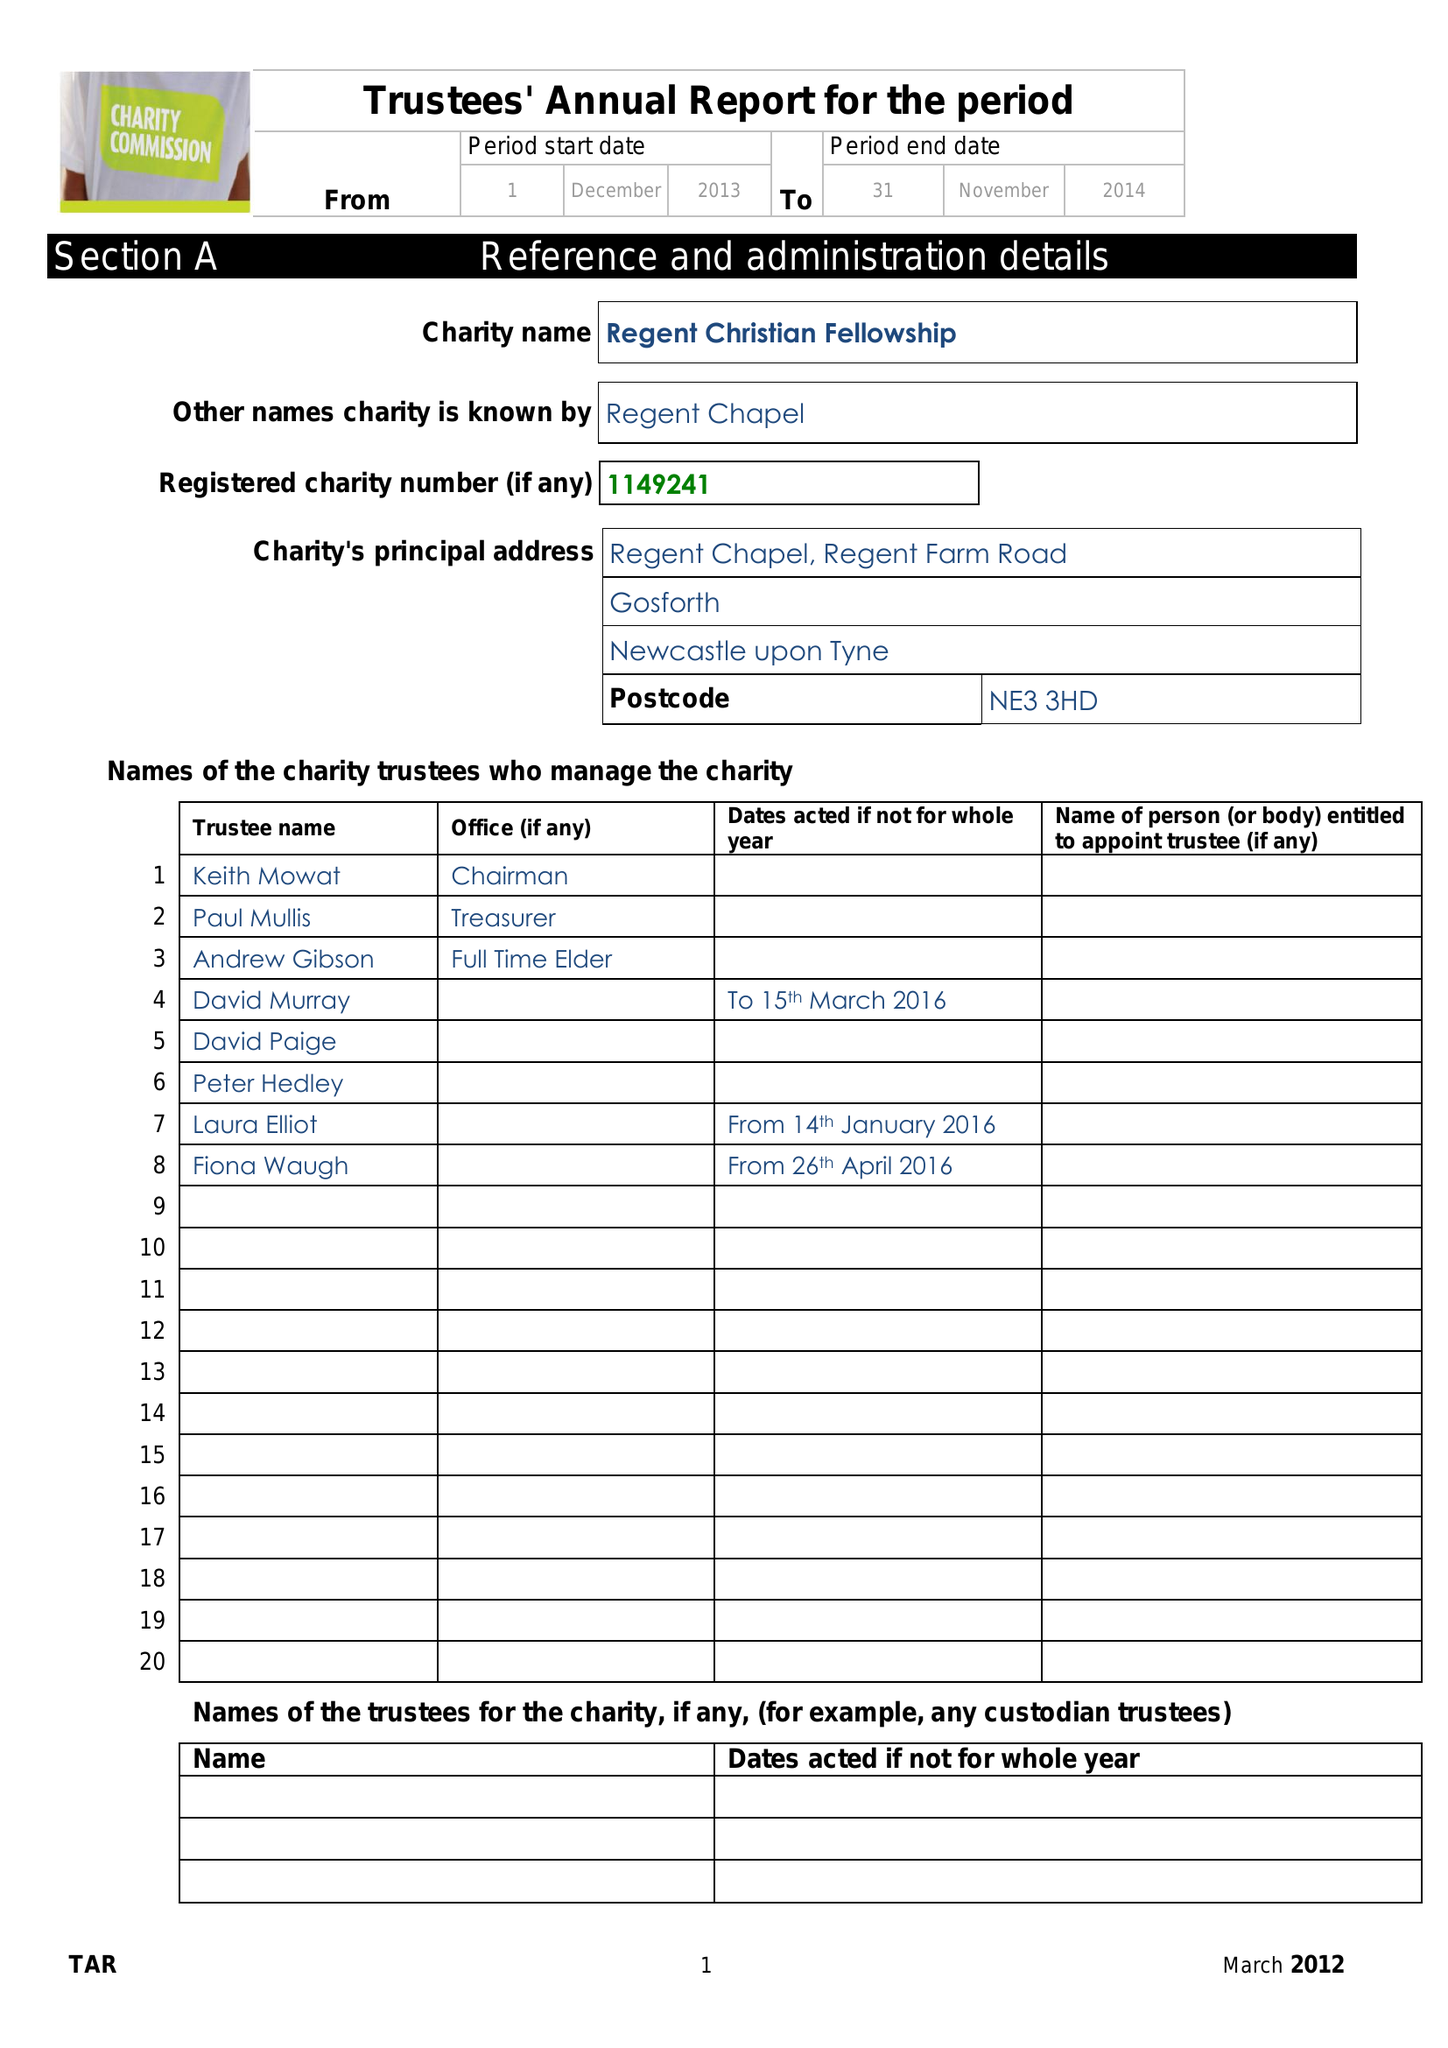What is the value for the report_date?
Answer the question using a single word or phrase. 2016-11-30 